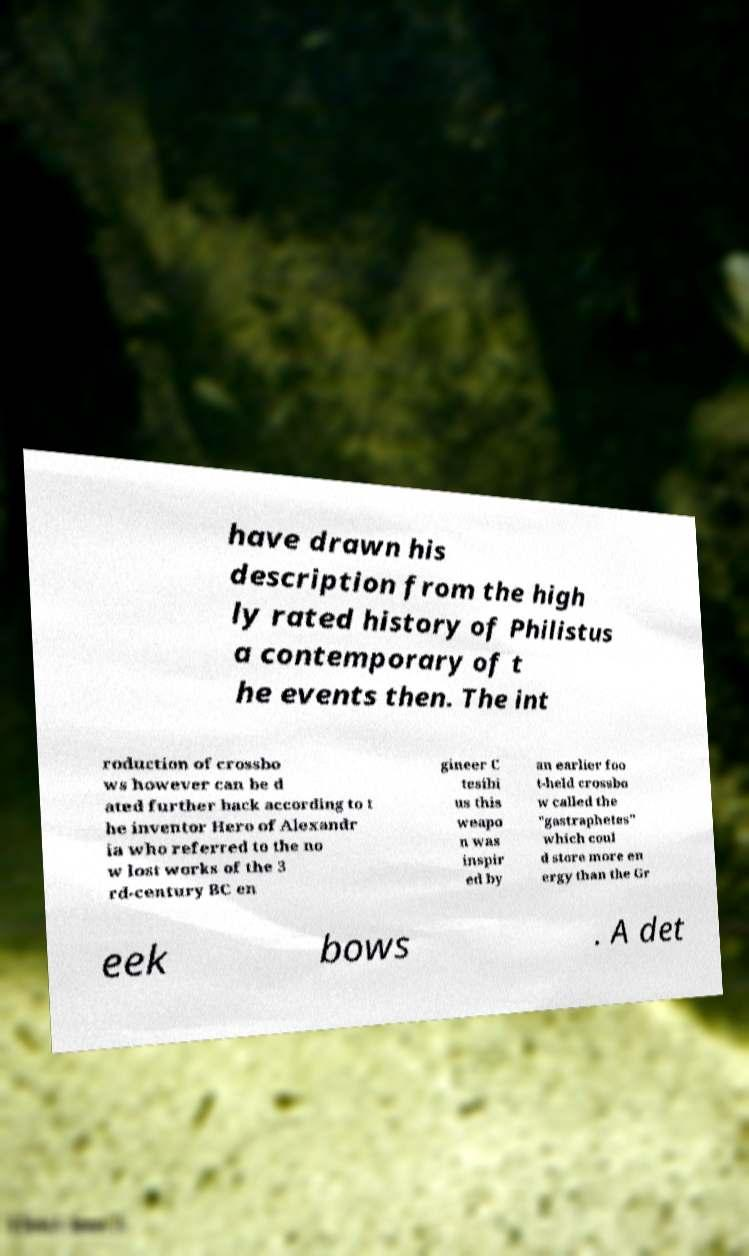Please identify and transcribe the text found in this image. have drawn his description from the high ly rated history of Philistus a contemporary of t he events then. The int roduction of crossbo ws however can be d ated further back according to t he inventor Hero of Alexandr ia who referred to the no w lost works of the 3 rd-century BC en gineer C tesibi us this weapo n was inspir ed by an earlier foo t-held crossbo w called the "gastraphetes" which coul d store more en ergy than the Gr eek bows . A det 